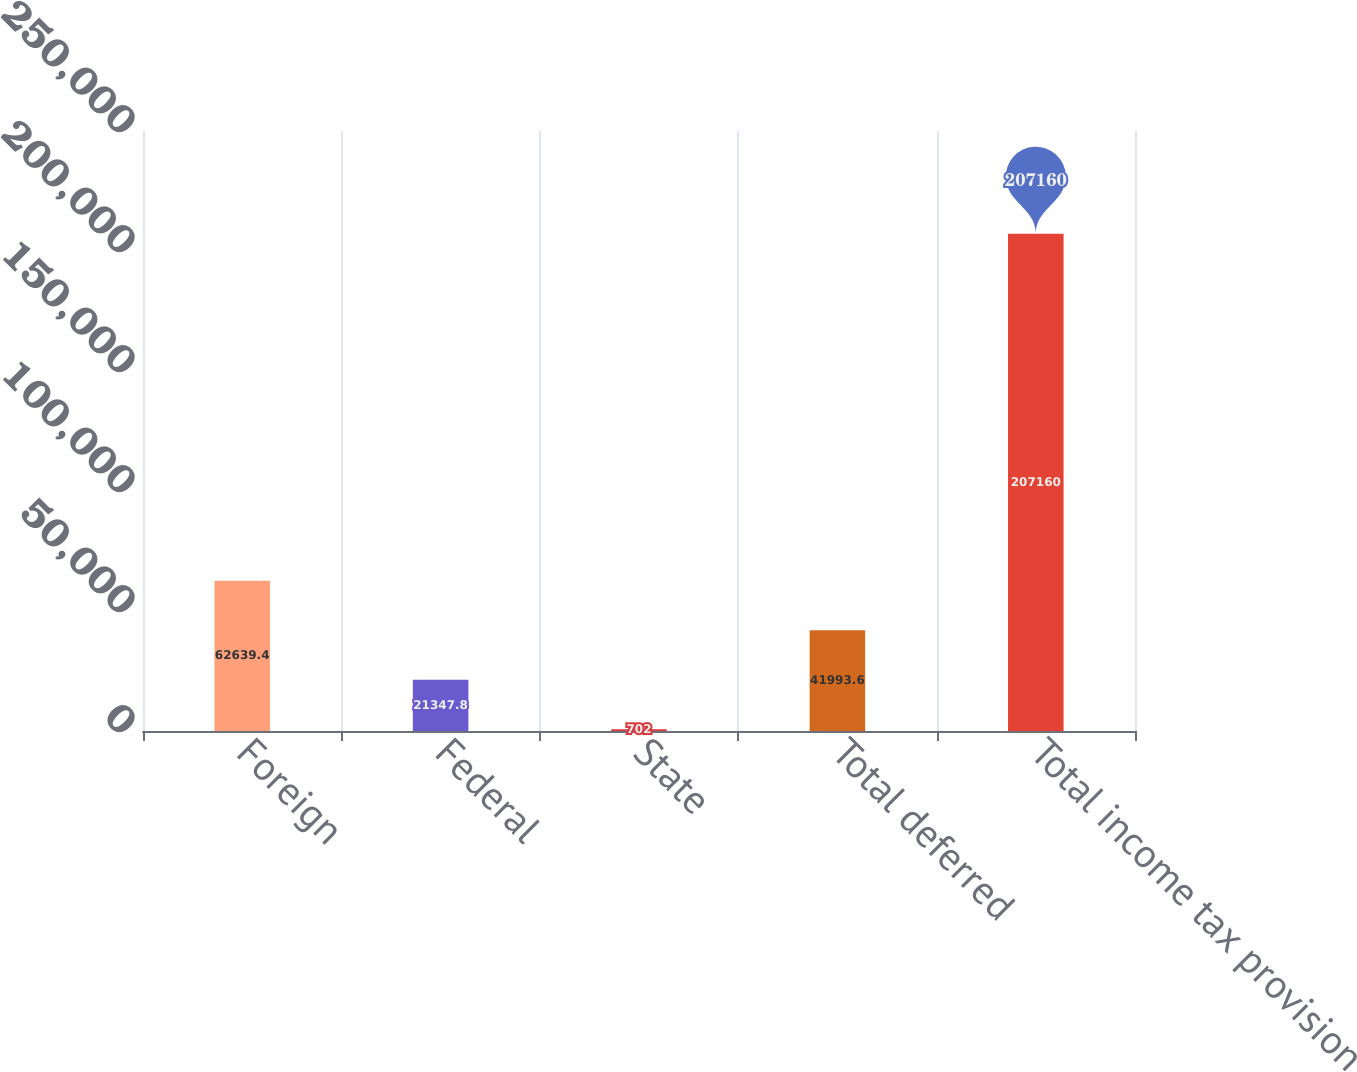Convert chart to OTSL. <chart><loc_0><loc_0><loc_500><loc_500><bar_chart><fcel>Foreign<fcel>Federal<fcel>State<fcel>Total deferred<fcel>Total income tax provision<nl><fcel>62639.4<fcel>21347.8<fcel>702<fcel>41993.6<fcel>207160<nl></chart> 